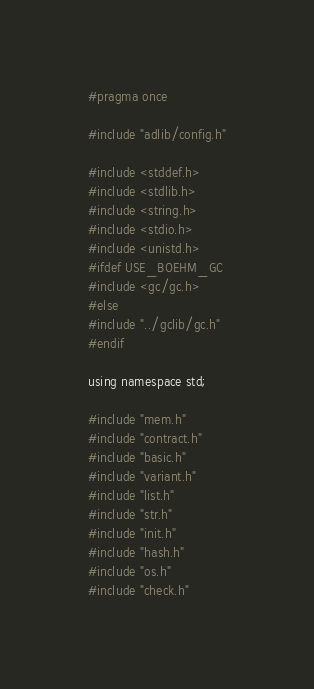<code> <loc_0><loc_0><loc_500><loc_500><_C_>#pragma once

#include "adlib/config.h"

#include <stddef.h>
#include <stdlib.h>
#include <string.h>
#include <stdio.h>
#include <unistd.h>
#ifdef USE_BOEHM_GC
#include <gc/gc.h>
#else
#include "../gclib/gc.h"
#endif

using namespace std;

#include "mem.h"
#include "contract.h"
#include "basic.h"
#include "variant.h"
#include "list.h"
#include "str.h"
#include "init.h"
#include "hash.h"
#include "os.h"
#include "check.h"
</code> 